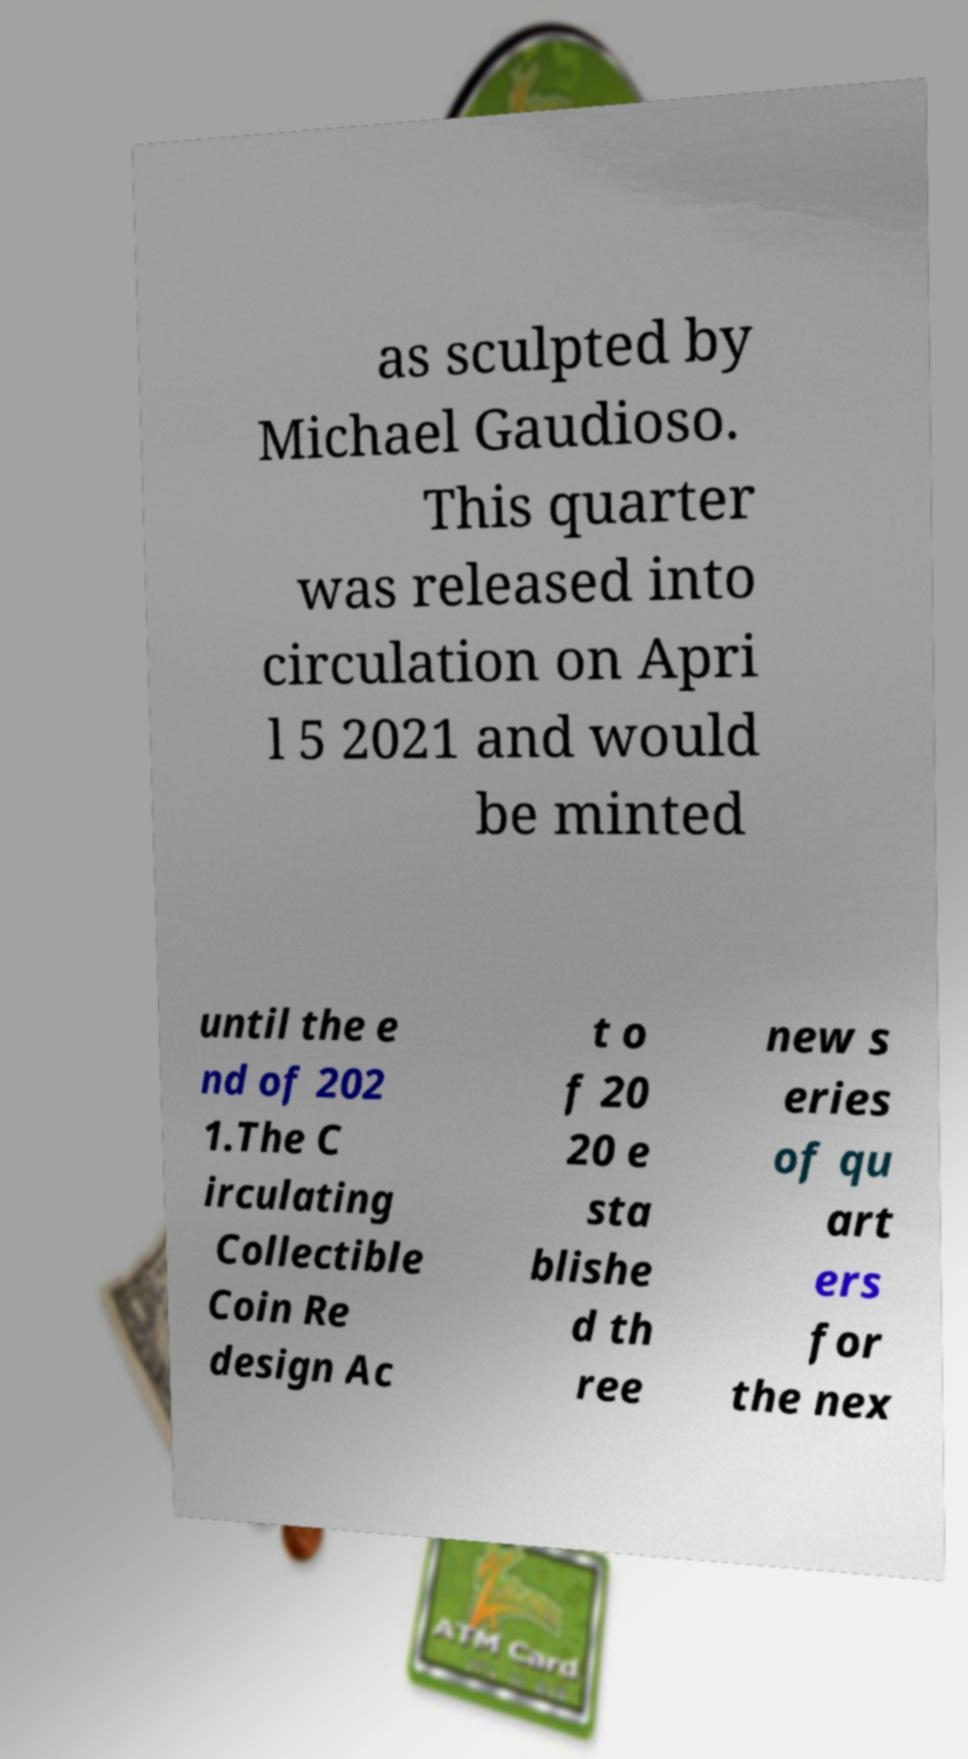Could you extract and type out the text from this image? as sculpted by Michael Gaudioso. This quarter was released into circulation on Apri l 5 2021 and would be minted until the e nd of 202 1.The C irculating Collectible Coin Re design Ac t o f 20 20 e sta blishe d th ree new s eries of qu art ers for the nex 